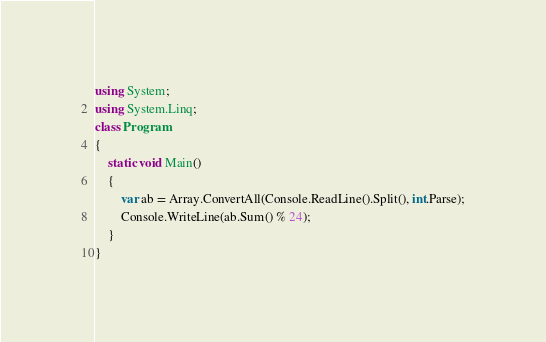Convert code to text. <code><loc_0><loc_0><loc_500><loc_500><_C#_>using System;
using System.Linq;
class Program
{
    static void Main()
    {
        var ab = Array.ConvertAll(Console.ReadLine().Split(), int.Parse);
        Console.WriteLine(ab.Sum() % 24);
    }
}
</code> 